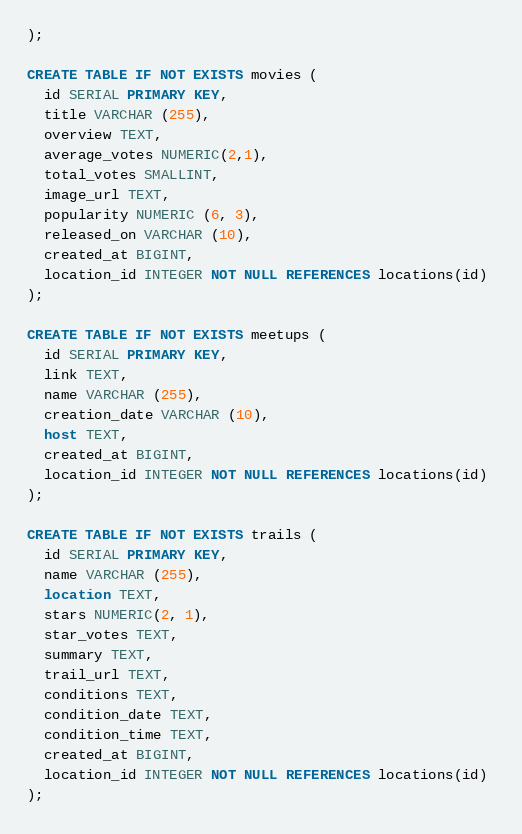Convert code to text. <code><loc_0><loc_0><loc_500><loc_500><_SQL_>);

CREATE TABLE IF NOT EXISTS movies (
  id SERIAL PRIMARY KEY,
  title VARCHAR (255),
  overview TEXT,
  average_votes NUMERIC(2,1),
  total_votes SMALLINT,
  image_url TEXT,
  popularity NUMERIC (6, 3),
  released_on VARCHAR (10),
  created_at BIGINT,
  location_id INTEGER NOT NULL REFERENCES locations(id) 
);

CREATE TABLE IF NOT EXISTS meetups (
  id SERIAL PRIMARY KEY,
  link TEXT,
  name VARCHAR (255),
  creation_date VARCHAR (10),
  host TEXT,
  created_at BIGINT,
  location_id INTEGER NOT NULL REFERENCES locations(id) 
);

CREATE TABLE IF NOT EXISTS trails (
  id SERIAL PRIMARY KEY,
  name VARCHAR (255),
  location TEXT,
  stars NUMERIC(2, 1),
  star_votes TEXT,
  summary TEXT,
  trail_url TEXT,
  conditions TEXT,
  condition_date TEXT,
  condition_time TEXT,
  created_at BIGINT,
  location_id INTEGER NOT NULL REFERENCES locations(id) 
);</code> 